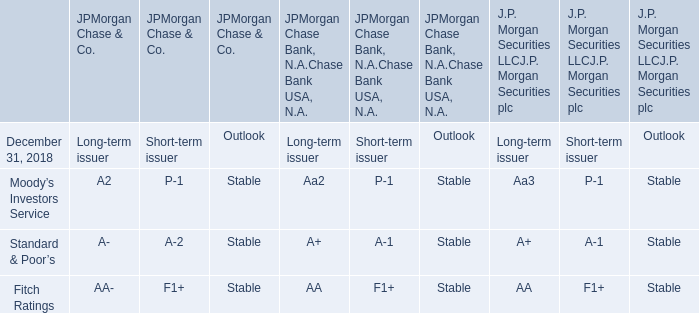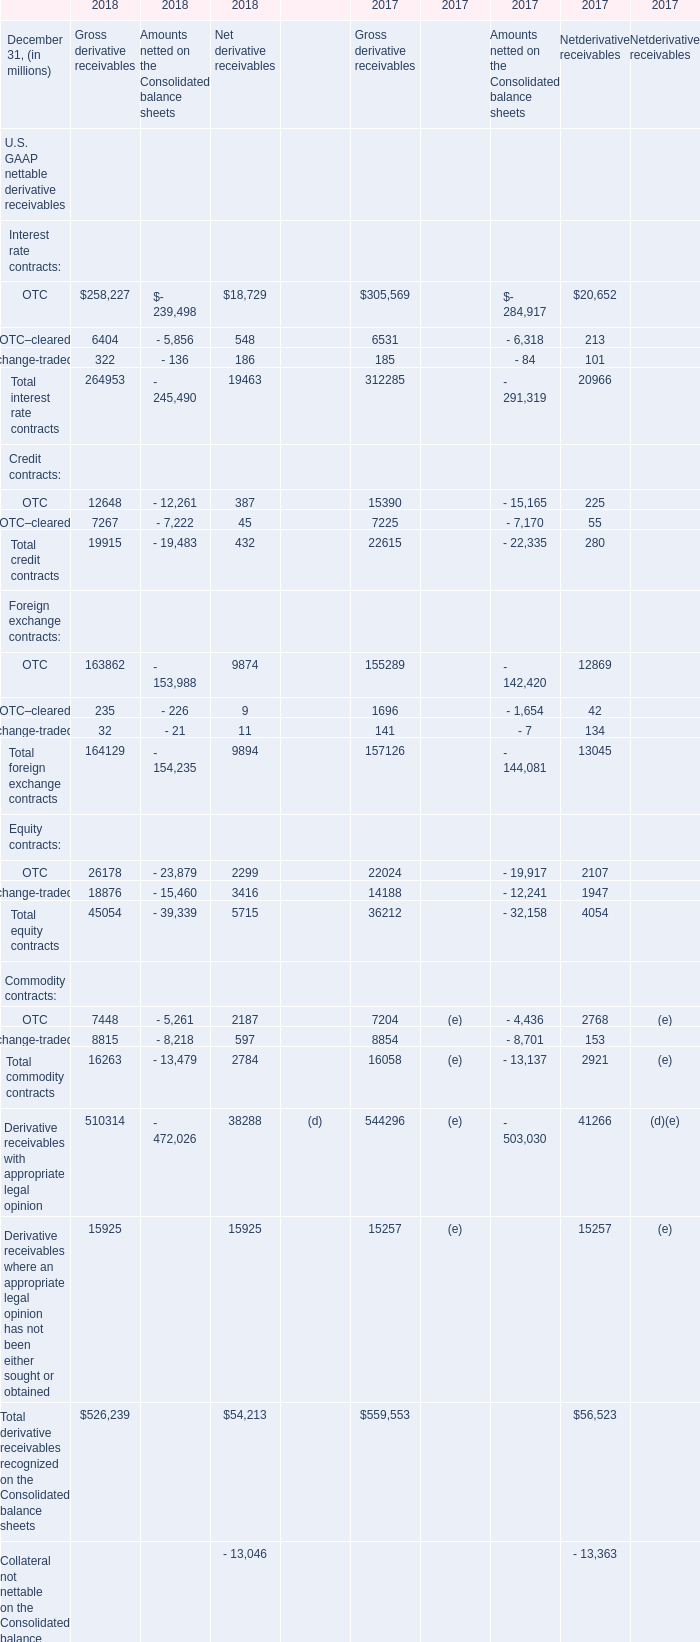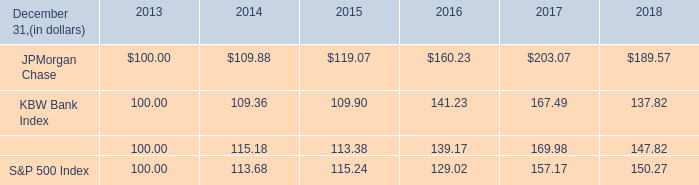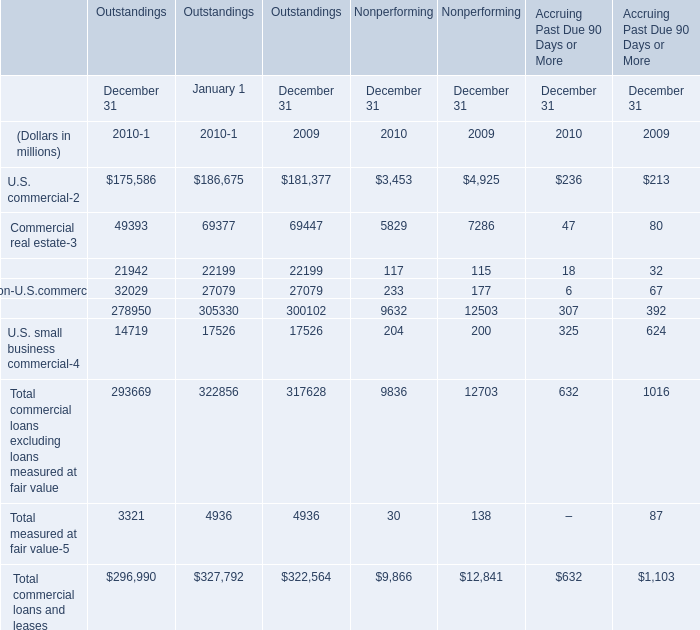what is the estimated average return for the s&p financial index and the s&p 500 index in the firs year of the investment of $ 100? 
Computations: ((((115.18 / 100) - 1) + ((113.68 / 100) - 1)) / 2)
Answer: 0.1443. 